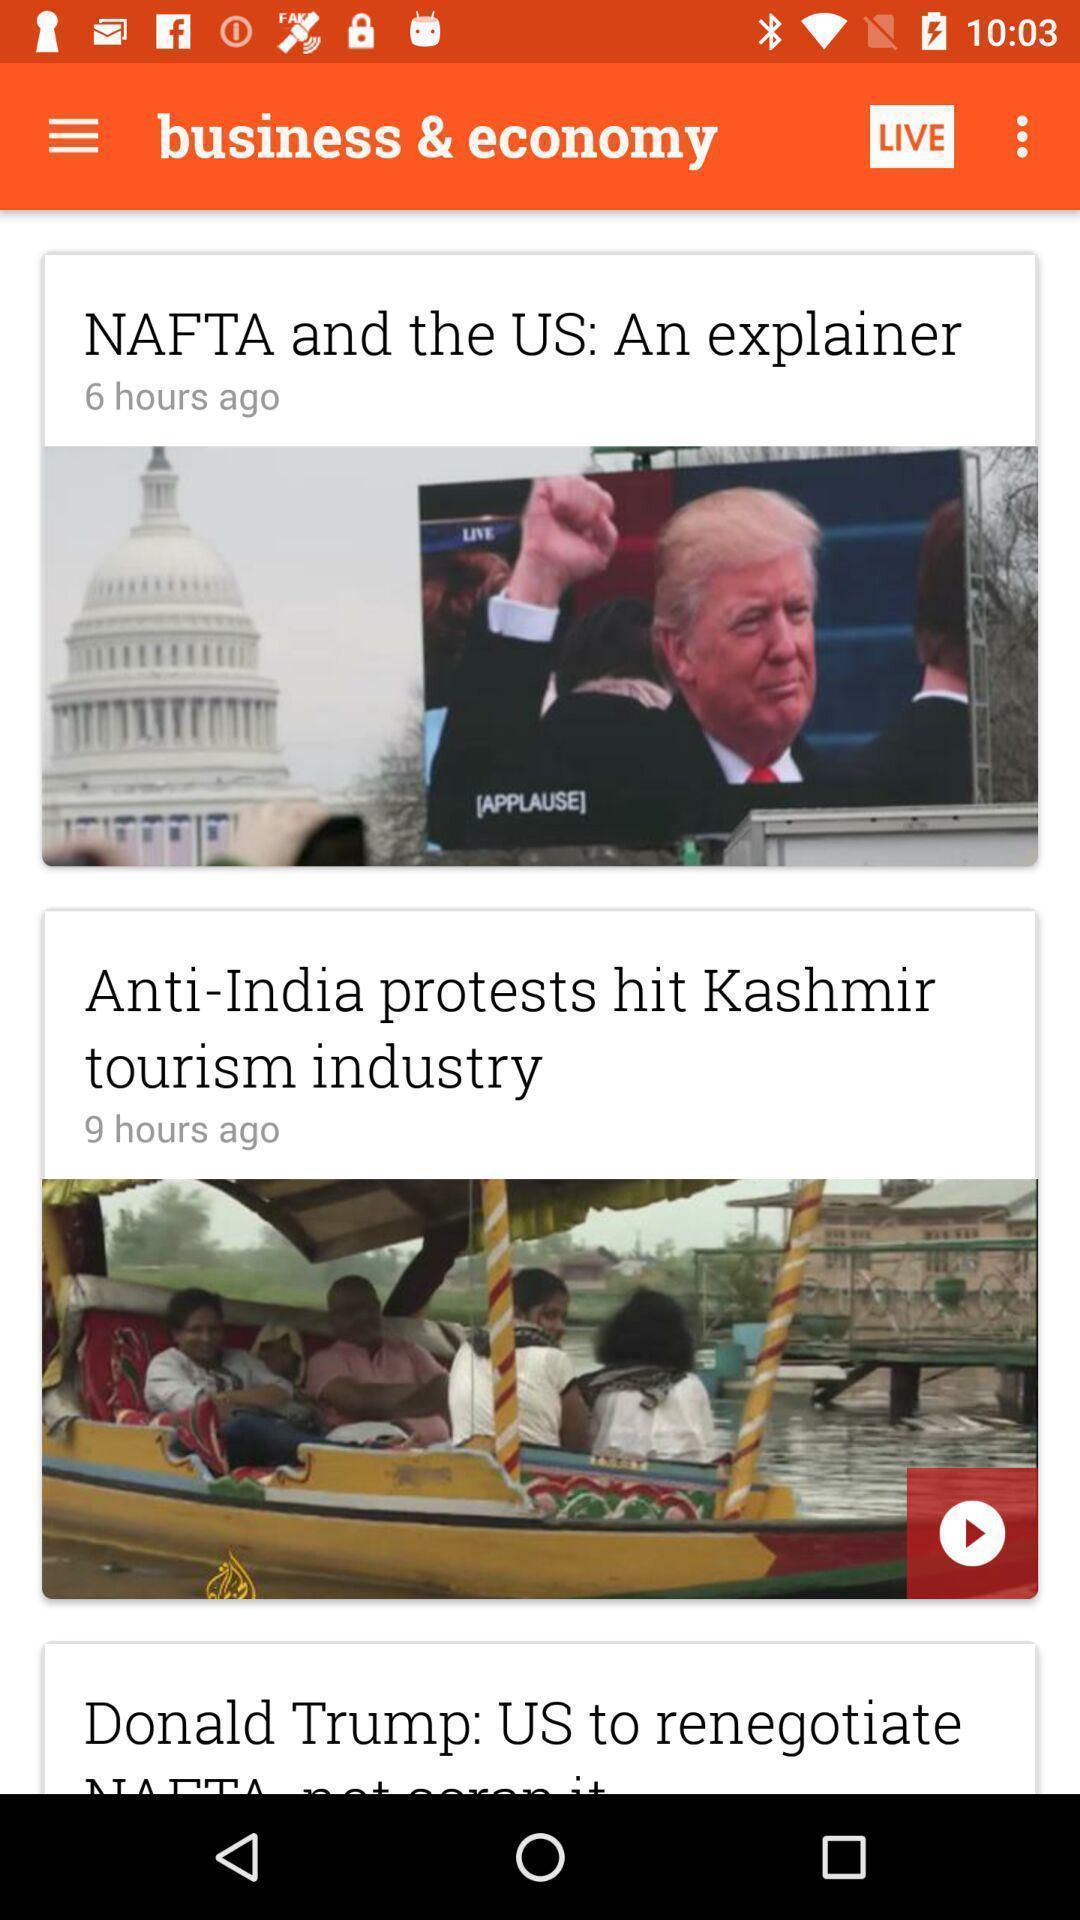What details can you identify in this image? Screen displaying the thumbnails of news articles. 